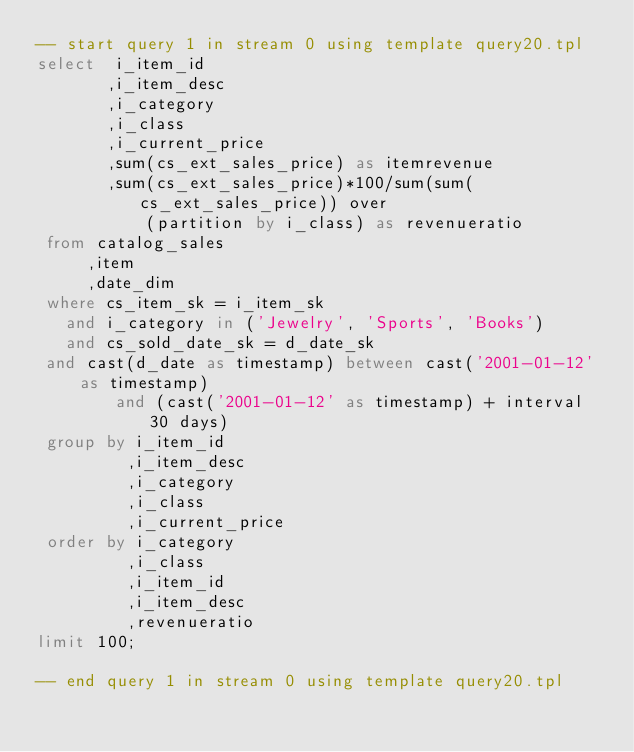Convert code to text. <code><loc_0><loc_0><loc_500><loc_500><_SQL_>-- start query 1 in stream 0 using template query20.tpl
select  i_item_id
       ,i_item_desc 
       ,i_category 
       ,i_class 
       ,i_current_price
       ,sum(cs_ext_sales_price) as itemrevenue 
       ,sum(cs_ext_sales_price)*100/sum(sum(cs_ext_sales_price)) over
           (partition by i_class) as revenueratio
 from	catalog_sales
     ,item 
     ,date_dim
 where cs_item_sk = i_item_sk 
   and i_category in ('Jewelry', 'Sports', 'Books')
   and cs_sold_date_sk = d_date_sk
 and cast(d_date as timestamp) between cast('2001-01-12' as timestamp) 
 				and (cast('2001-01-12' as timestamp) + interval 30 days)
 group by i_item_id
         ,i_item_desc 
         ,i_category
         ,i_class
         ,i_current_price
 order by i_category
         ,i_class
         ,i_item_id
         ,i_item_desc
         ,revenueratio
limit 100;

-- end query 1 in stream 0 using template query20.tpl
</code> 